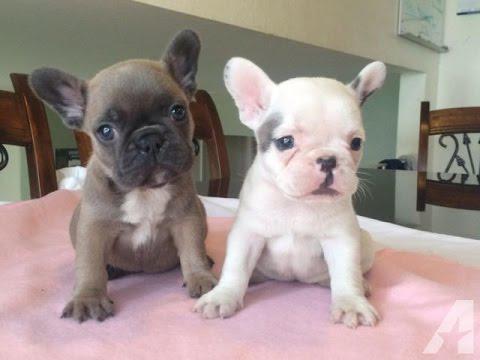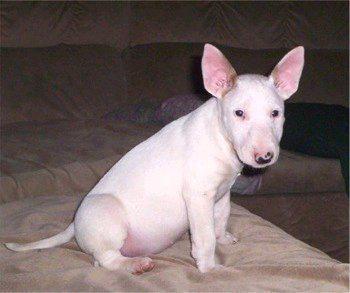The first image is the image on the left, the second image is the image on the right. Given the left and right images, does the statement "There are at most two dogs." hold true? Answer yes or no. No. The first image is the image on the left, the second image is the image on the right. For the images shown, is this caption "The image on the left contains no more than one dog with its ears perked up." true? Answer yes or no. No. 